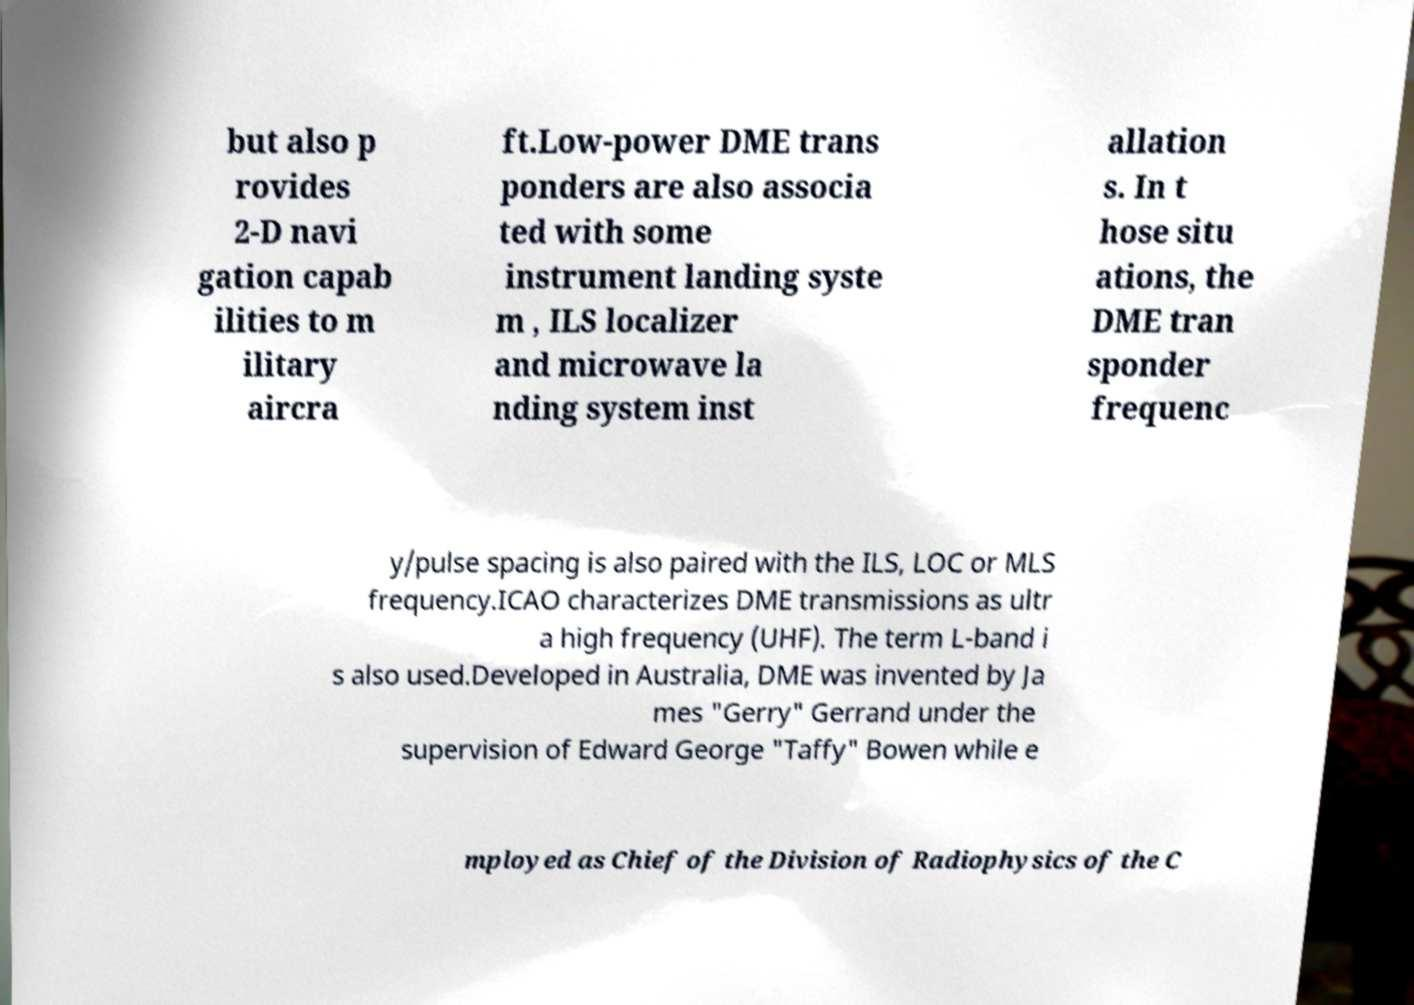Can you read and provide the text displayed in the image?This photo seems to have some interesting text. Can you extract and type it out for me? but also p rovides 2-D navi gation capab ilities to m ilitary aircra ft.Low-power DME trans ponders are also associa ted with some instrument landing syste m , ILS localizer and microwave la nding system inst allation s. In t hose situ ations, the DME tran sponder frequenc y/pulse spacing is also paired with the ILS, LOC or MLS frequency.ICAO characterizes DME transmissions as ultr a high frequency (UHF). The term L-band i s also used.Developed in Australia, DME was invented by Ja mes "Gerry" Gerrand under the supervision of Edward George "Taffy" Bowen while e mployed as Chief of the Division of Radiophysics of the C 